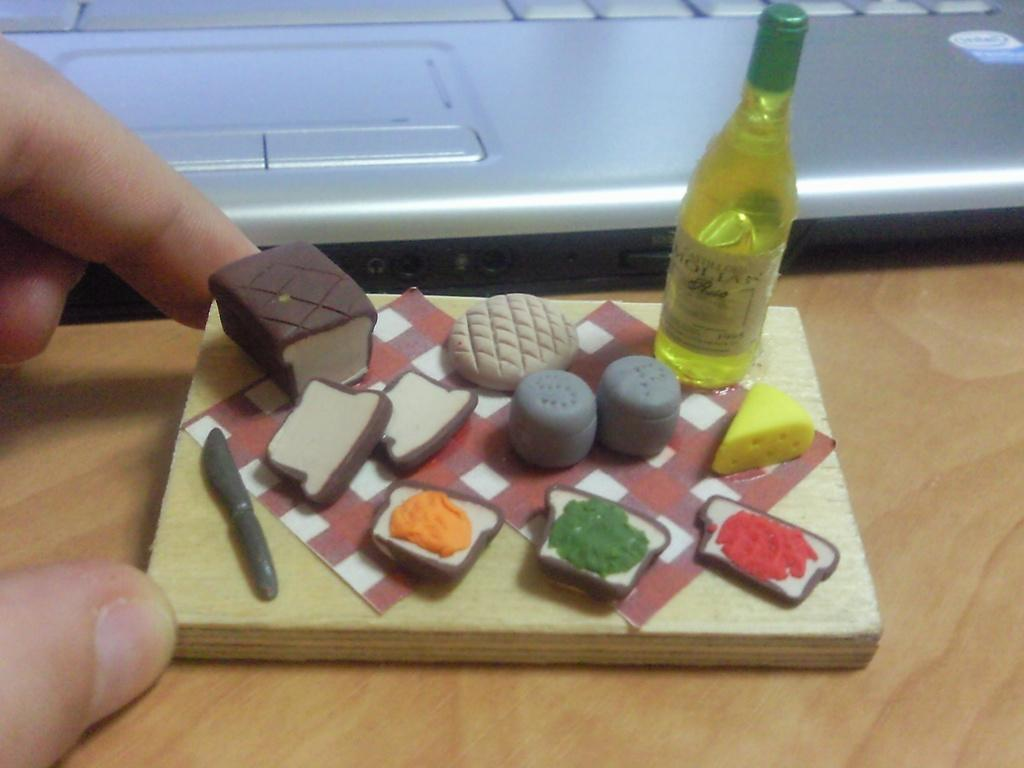Who or what is present in the image? There is a person in the image. What is the person holding in the image? The person is holding a wood block. What can be found on the wood block? There are food items and decorative items on the wood block. Is there any other object on the wood block? Yes, there is a bottle on the wood block. What type of haircut does the person have in the image? There is no information about the person's haircut in the image. How many sticks are visible in the image? There are no sticks visible in the image. 